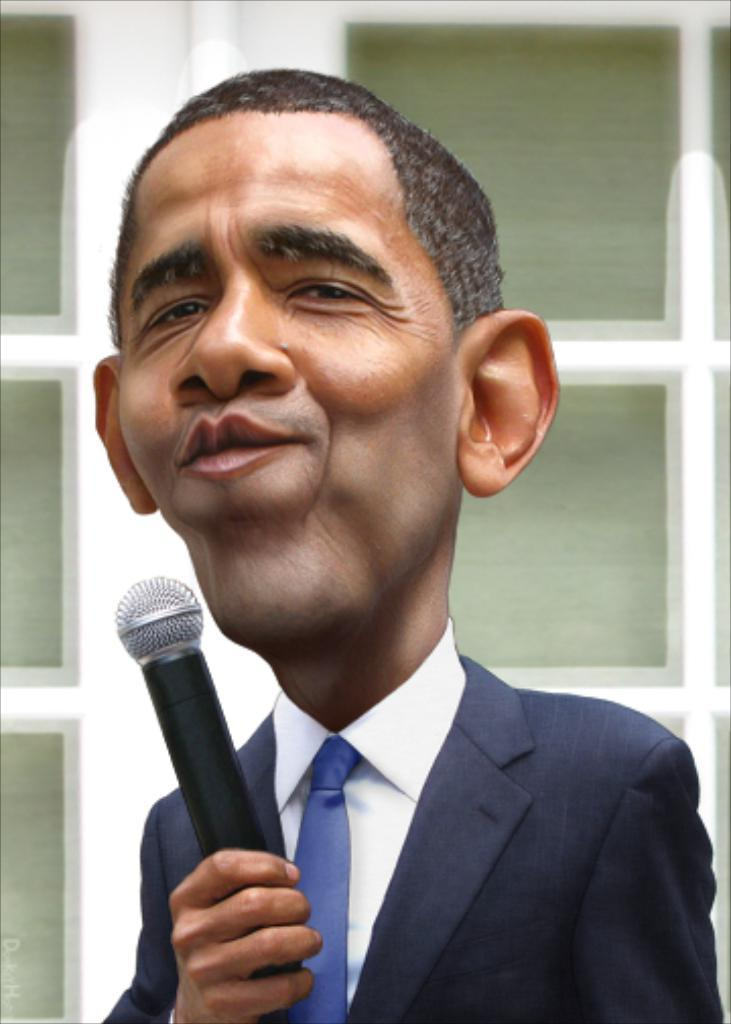What is the man in the image wearing? The man is wearing a suit, a white shirt, and a tie. What is the man holding in his hand? The man is holding a microphone in his hand. What can be seen in the background of the image? There is a door in the background of the image. What is the color and material of the door frame? The door has a white wooden frame. What time of day is it based on the man's knee in the image? The man's knee does not indicate the time of day, and there is no information about the time in the image. 